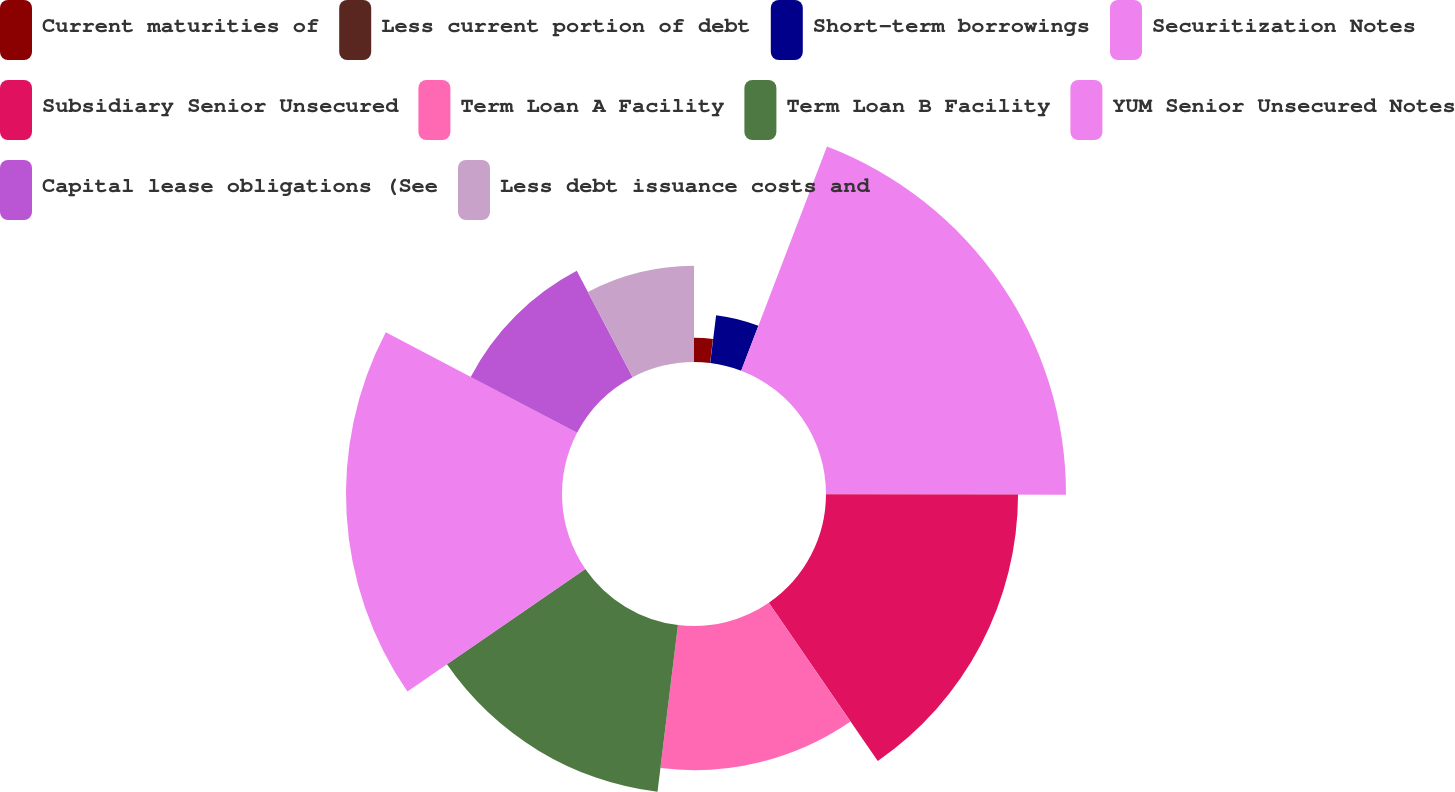<chart> <loc_0><loc_0><loc_500><loc_500><pie_chart><fcel>Current maturities of<fcel>Less current portion of debt<fcel>Short-term borrowings<fcel>Securitization Notes<fcel>Subsidiary Senior Unsecured<fcel>Term Loan A Facility<fcel>Term Loan B Facility<fcel>YUM Senior Unsecured Notes<fcel>Capital lease obligations (See<fcel>Less debt issuance costs and<nl><fcel>1.94%<fcel>0.02%<fcel>3.86%<fcel>19.22%<fcel>15.38%<fcel>11.54%<fcel>13.46%<fcel>17.3%<fcel>9.62%<fcel>7.7%<nl></chart> 